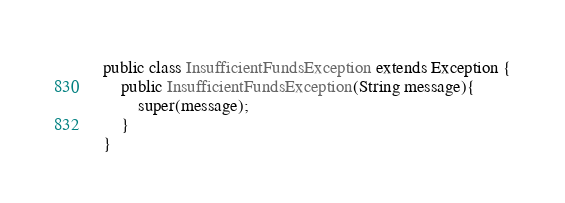Convert code to text. <code><loc_0><loc_0><loc_500><loc_500><_Java_>
public class InsufficientFundsException extends Exception {
	public InsufficientFundsException(String message){
		super(message);
	}
}
</code> 